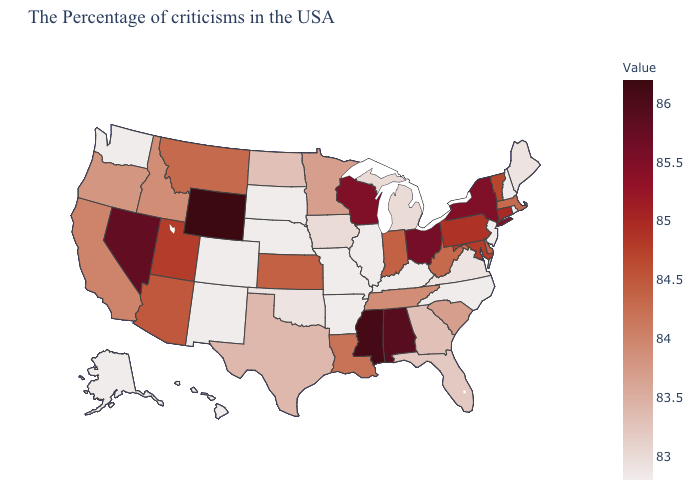Which states have the lowest value in the Northeast?
Keep it brief. Rhode Island, New Hampshire, New Jersey. Among the states that border Utah , does New Mexico have the lowest value?
Write a very short answer. Yes. Among the states that border Mississippi , which have the lowest value?
Be succinct. Arkansas. Which states have the lowest value in the MidWest?
Concise answer only. Illinois, Missouri, Nebraska, South Dakota. Among the states that border New Mexico , which have the highest value?
Quick response, please. Utah. Does Washington have the lowest value in the West?
Give a very brief answer. Yes. 